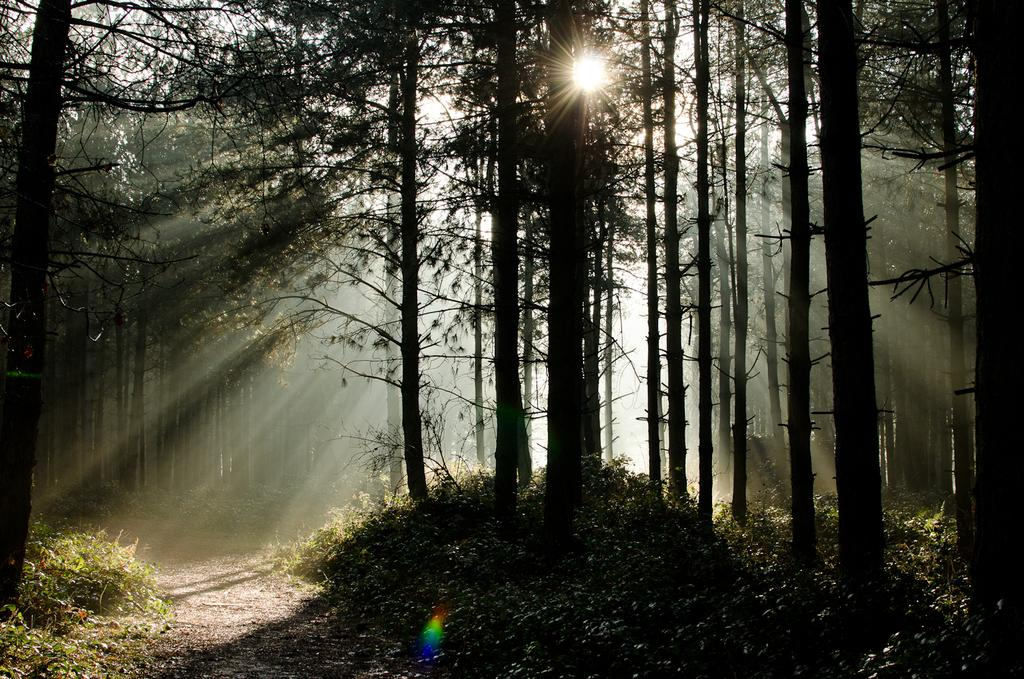What type of vegetation is present in the image? There is grass in the image. What can be seen in the background of the image? There are trees and the sun visible in the background of the image. Where is the lunchroom located in the image? There is no lunchroom present in the image. What type of thing can be seen in the market in the image? There is no market present in the image. 